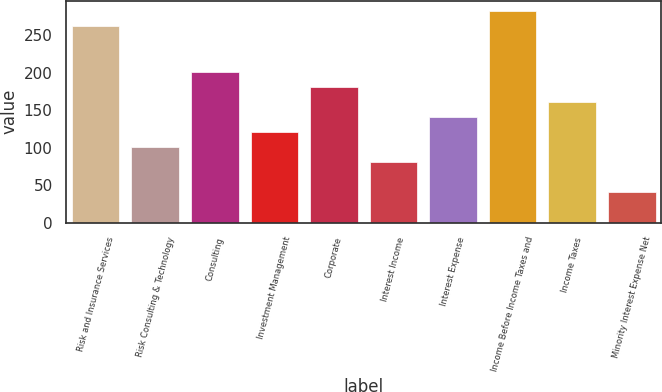Convert chart to OTSL. <chart><loc_0><loc_0><loc_500><loc_500><bar_chart><fcel>Risk and Insurance Services<fcel>Risk Consulting & Technology<fcel>Consulting<fcel>Investment Management<fcel>Corporate<fcel>Interest Income<fcel>Interest Expense<fcel>Income Before Income Taxes and<fcel>Income Taxes<fcel>Minority Interest Expense Net<nl><fcel>261.28<fcel>100.64<fcel>201.04<fcel>120.72<fcel>180.96<fcel>80.56<fcel>140.8<fcel>281.36<fcel>160.88<fcel>40.4<nl></chart> 